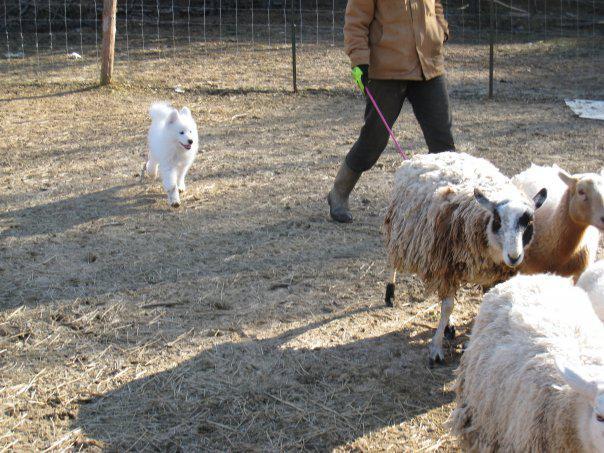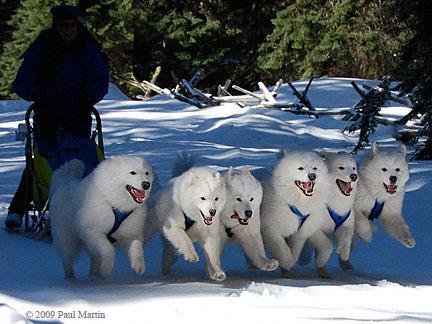The first image is the image on the left, the second image is the image on the right. Evaluate the accuracy of this statement regarding the images: "A team of dogs is pulling a sled in one of the images.". Is it true? Answer yes or no. Yes. The first image is the image on the left, the second image is the image on the right. For the images displayed, is the sentence "An image shows a rider in a sled behind a team of white sled dogs." factually correct? Answer yes or no. Yes. 